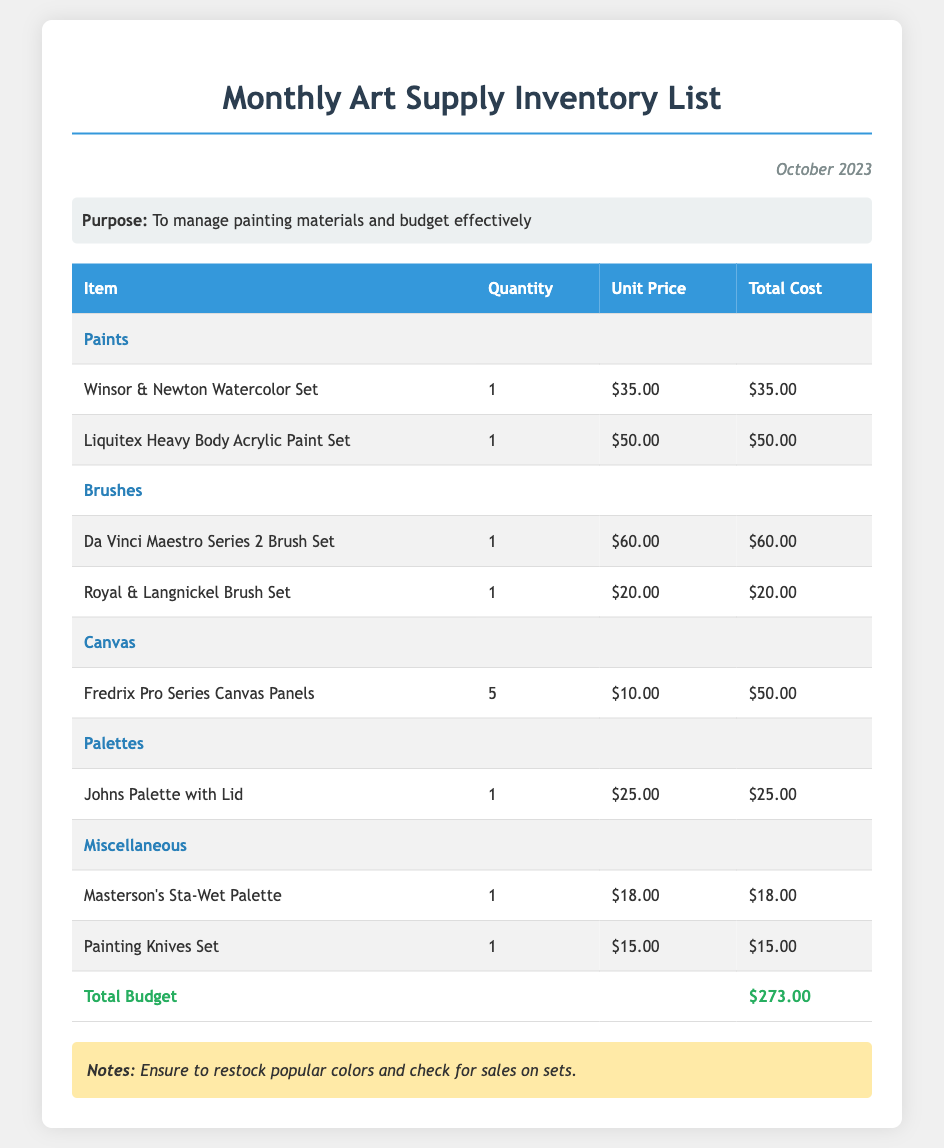What is the total budget? The total budget is provided at the end of the inventory list, which sums the costs of all items.
Answer: $273.00 How many Winsor & Newton Watercolor Set items are listed? The document specifies the number of each item, which for the Winsor & Newton Watercolor Set is 1.
Answer: 1 What category includes the Da Vinci Maestro Series 2 Brush Set? The Da Vinci Maestro Series 2 Brush Set is categorized under Brushes.
Answer: Brushes What is the unit price of the Liquitex Heavy Body Acrylic Paint Set? The document lists the unit price for this item, which is $50.00.
Answer: $50.00 Which item has the highest total cost? To determine this, we must compare the total costs of all items; the Da Vinci Maestro Series 2 Brush Set is the highest at $60.00.
Answer: Da Vinci Maestro Series 2 Brush Set What is the purpose of this document? The document states its purpose clearly, focusing on management of painting materials and budget.
Answer: To manage painting materials and budget effectively How many Fredrix Pro Series Canvas Panels are listed? The inventory details specify there are 5 of the Fredrix Pro Series Canvas Panels.
Answer: 5 What is noted regarding popular colors? The notes section mentions that there is a need to restock popular colors.
Answer: Restock popular colors 